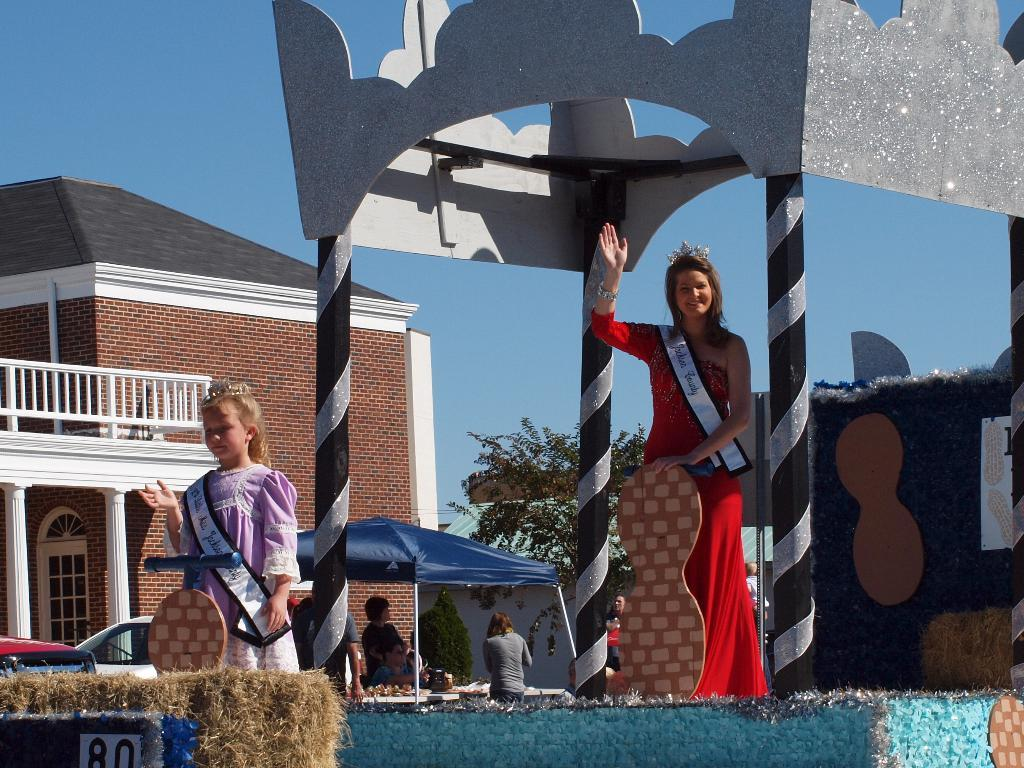What are the people in the image doing? The people are standing on a stage. How is the stage decorated? The stage is decorated with items. What can be seen in the background of the image? There is a house, trees, and the sky visible in the background of the image. How many spiders are crawling on the stage in the image? There are no spiders visible in the image; it features people standing on a stage with decorations. What color is the balloon tied to the microphone stand on the stage? There is no balloon present on the stage in the image. 